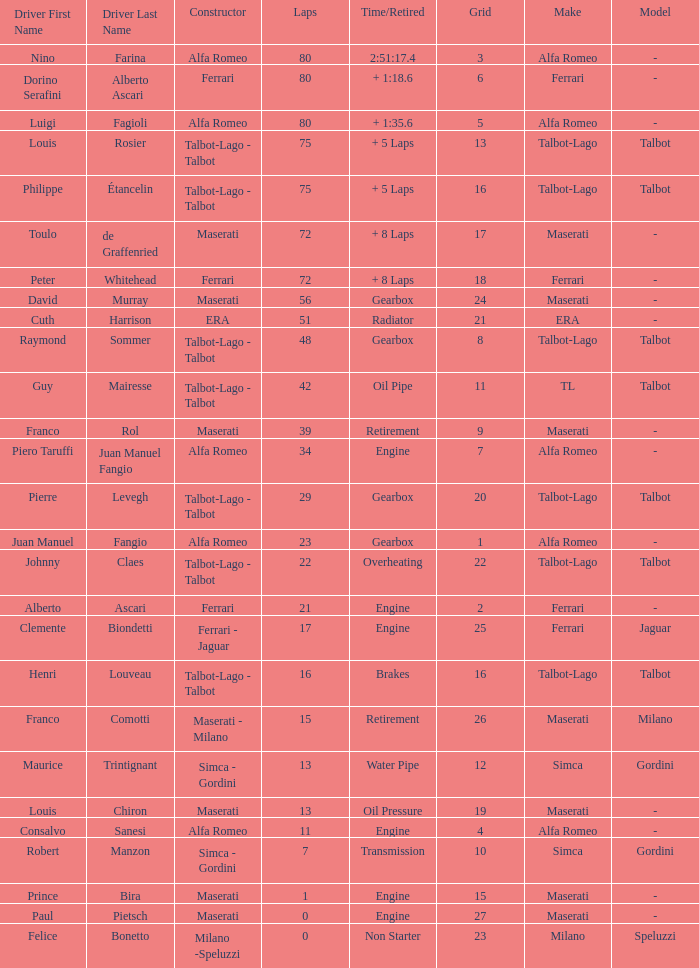What was the smallest grid for Prince bira? 15.0. 